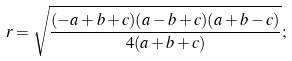Convert formula to latex. <formula><loc_0><loc_0><loc_500><loc_500>r = { \sqrt { \frac { ( - a + b + c ) ( a - b + c ) ( a + b - c ) } { 4 ( a + b + c ) } } } ;</formula> 